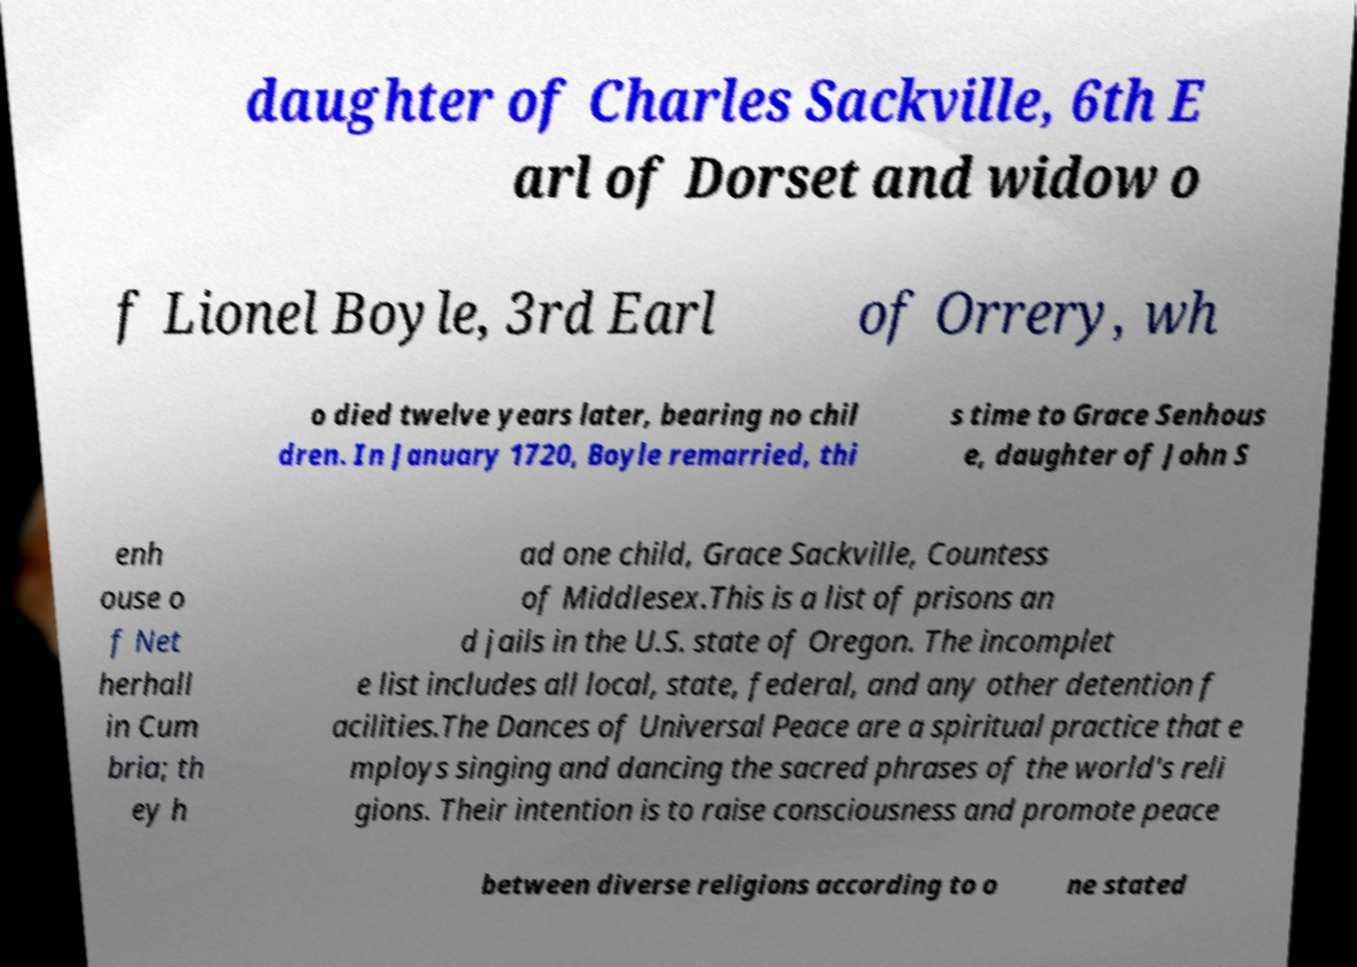I need the written content from this picture converted into text. Can you do that? daughter of Charles Sackville, 6th E arl of Dorset and widow o f Lionel Boyle, 3rd Earl of Orrery, wh o died twelve years later, bearing no chil dren. In January 1720, Boyle remarried, thi s time to Grace Senhous e, daughter of John S enh ouse o f Net herhall in Cum bria; th ey h ad one child, Grace Sackville, Countess of Middlesex.This is a list of prisons an d jails in the U.S. state of Oregon. The incomplet e list includes all local, state, federal, and any other detention f acilities.The Dances of Universal Peace are a spiritual practice that e mploys singing and dancing the sacred phrases of the world's reli gions. Their intention is to raise consciousness and promote peace between diverse religions according to o ne stated 